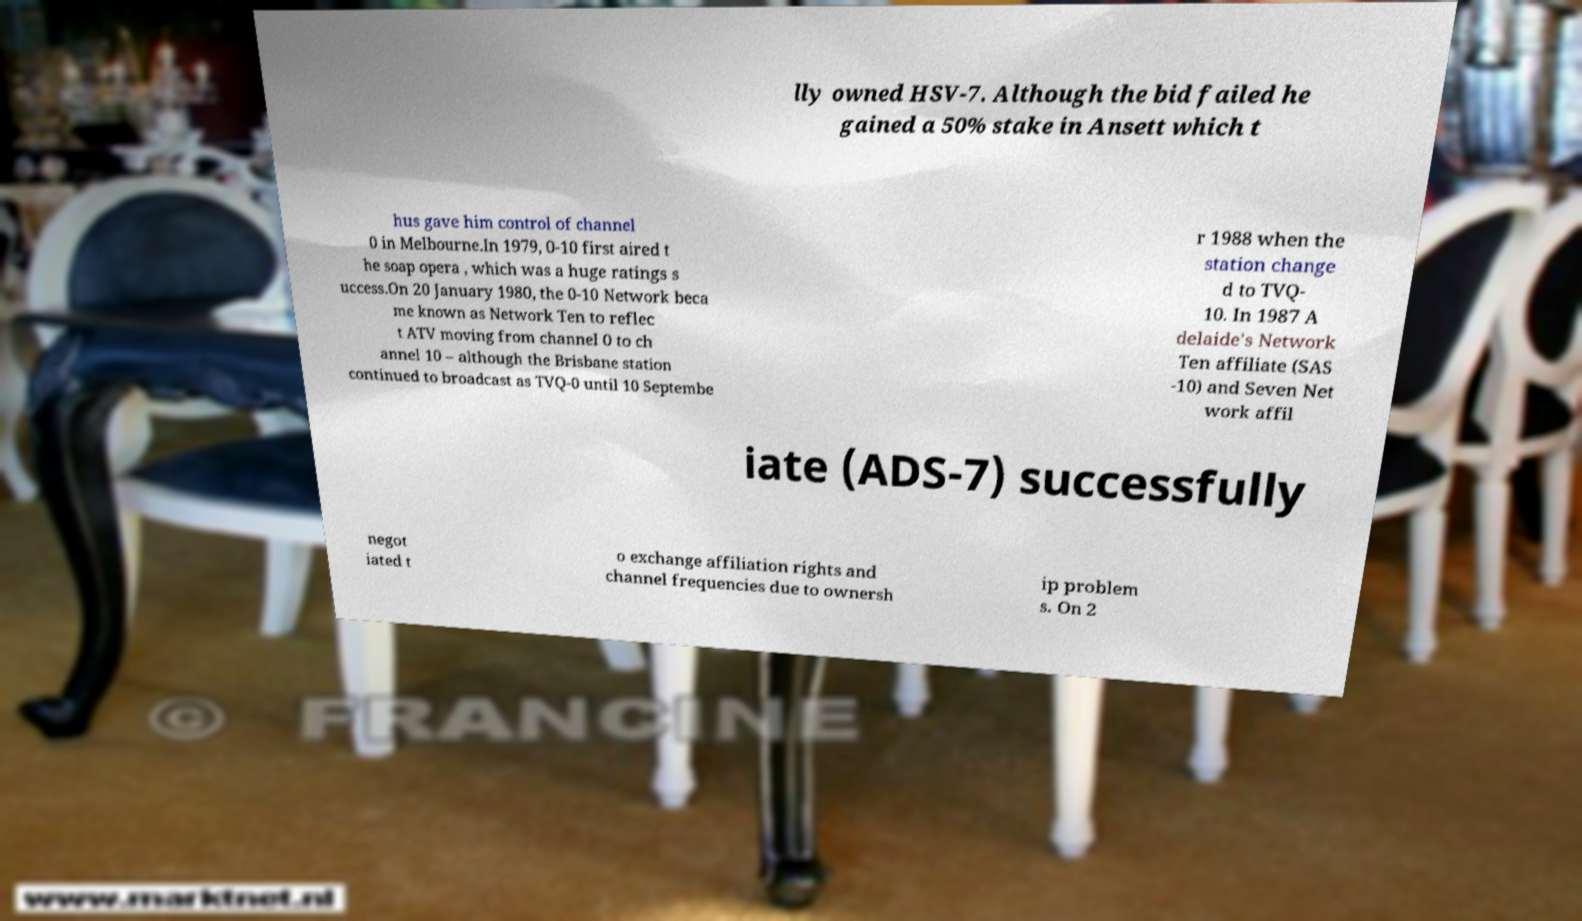Please identify and transcribe the text found in this image. lly owned HSV-7. Although the bid failed he gained a 50% stake in Ansett which t hus gave him control of channel 0 in Melbourne.In 1979, 0-10 first aired t he soap opera , which was a huge ratings s uccess.On 20 January 1980, the 0-10 Network beca me known as Network Ten to reflec t ATV moving from channel 0 to ch annel 10 – although the Brisbane station continued to broadcast as TVQ-0 until 10 Septembe r 1988 when the station change d to TVQ- 10. In 1987 A delaide's Network Ten affiliate (SAS -10) and Seven Net work affil iate (ADS-7) successfully negot iated t o exchange affiliation rights and channel frequencies due to ownersh ip problem s. On 2 